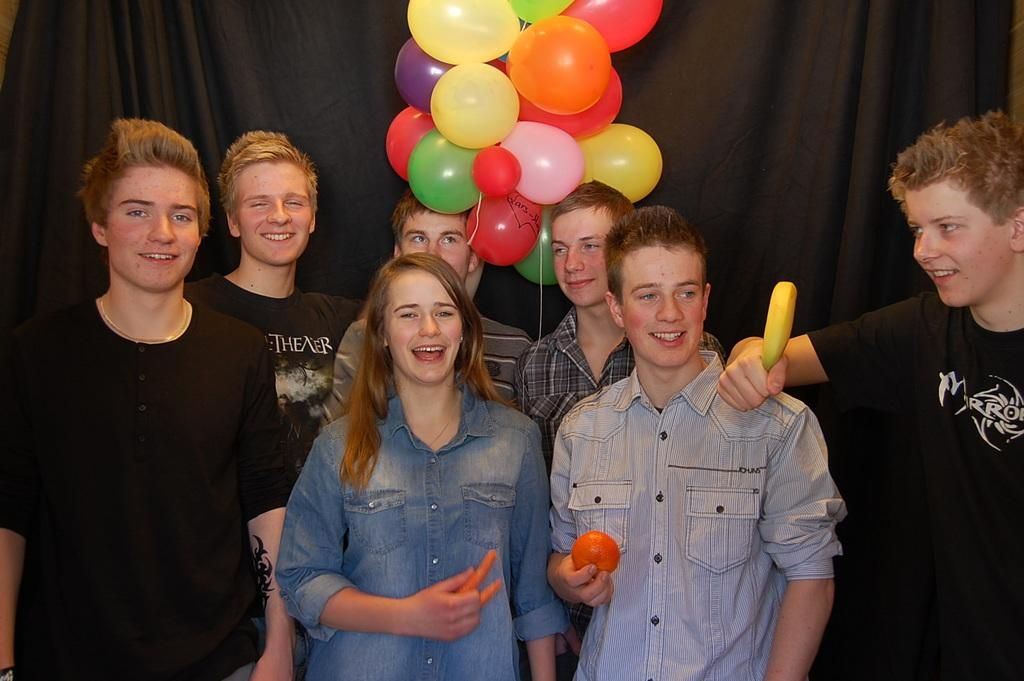What is happening with the group of people in the image? The people in the image are standing and smiling. What are the people holding in their hands? Three people are holding objects in their hands. What can be seen in the background of the image? There are balloons visible in the image. What color is the cloth in the image? There is a black cloth in the image. What type of silk is being used to make the robin's nest in the image? There is no robin or nest present in the image, so there is no silk being used. 